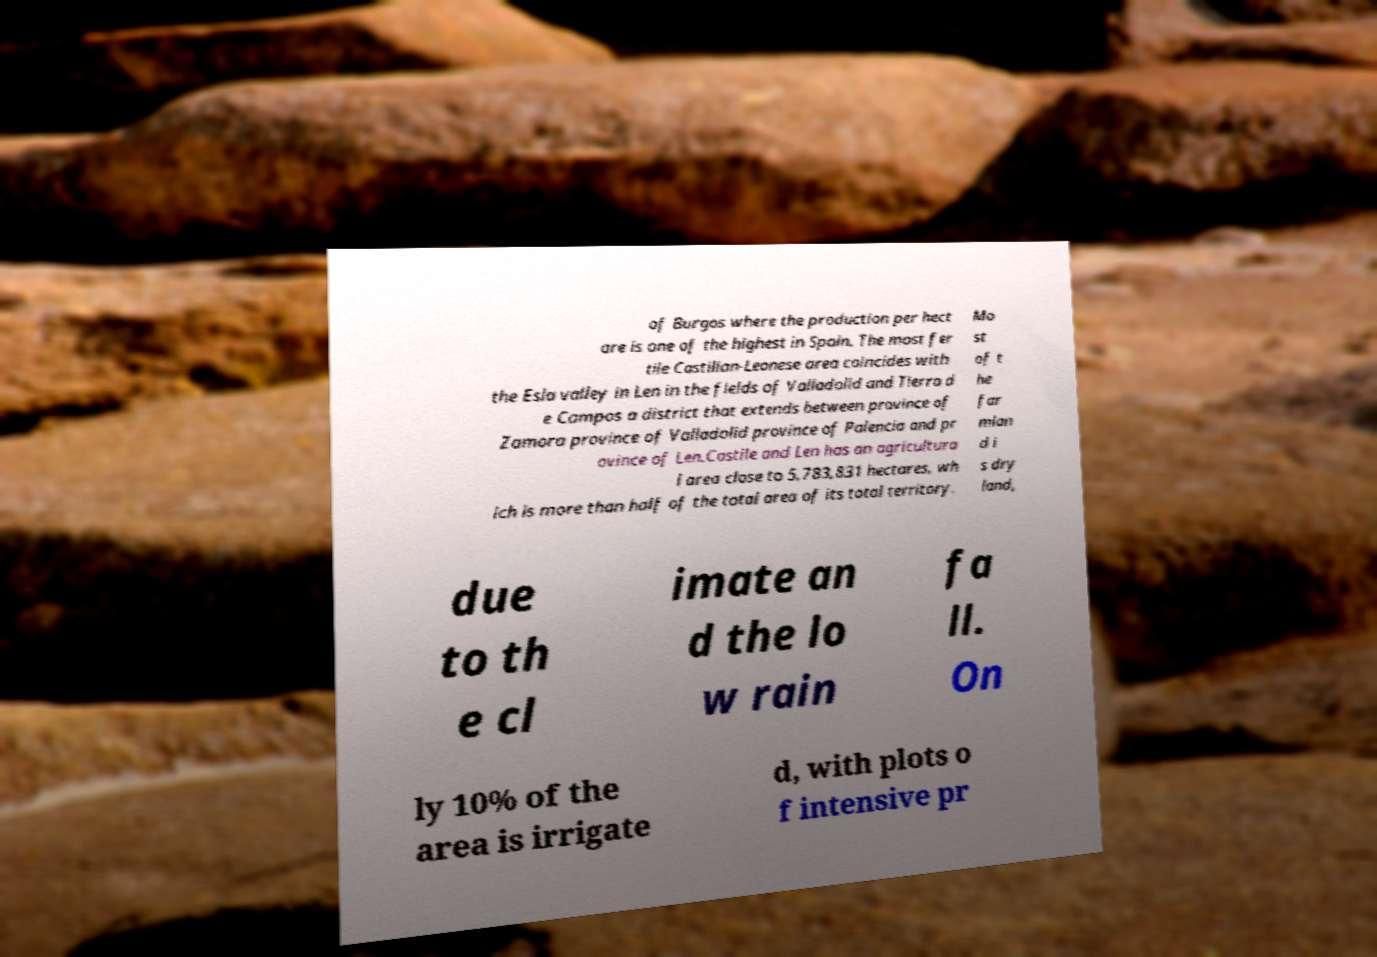Can you accurately transcribe the text from the provided image for me? of Burgos where the production per hect are is one of the highest in Spain. The most fer tile Castilian-Leonese area coincides with the Esla valley in Len in the fields of Valladolid and Tierra d e Campos a district that extends between province of Zamora province of Valladolid province of Palencia and pr ovince of Len.Castile and Len has an agricultura l area close to 5,783,831 hectares, wh ich is more than half of the total area of its total territory. Mo st of t he far mlan d i s dry land, due to th e cl imate an d the lo w rain fa ll. On ly 10% of the area is irrigate d, with plots o f intensive pr 